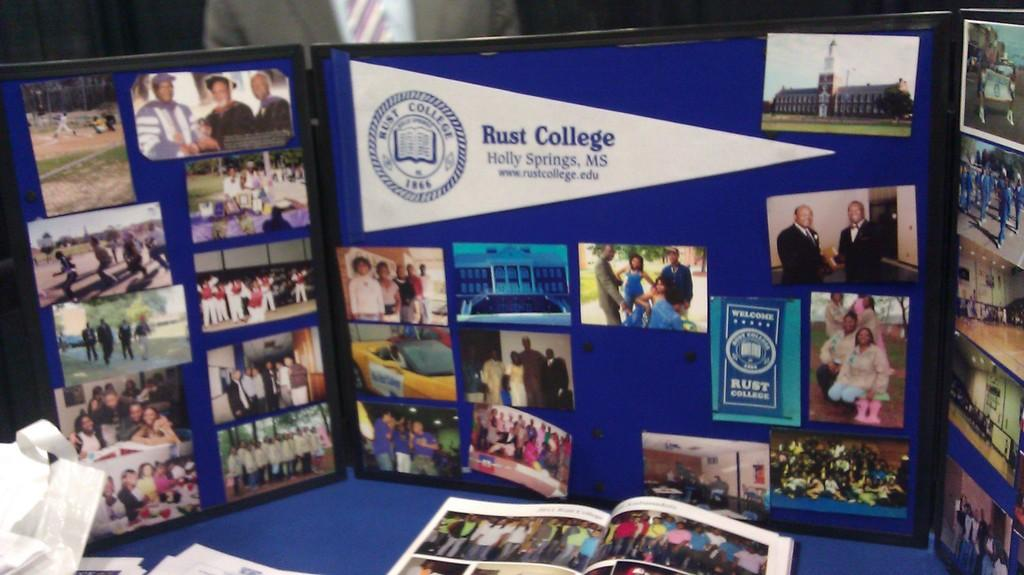<image>
Describe the image concisely. A tri-fold display of photographs from Rust College located in Holly Springs, MS. 